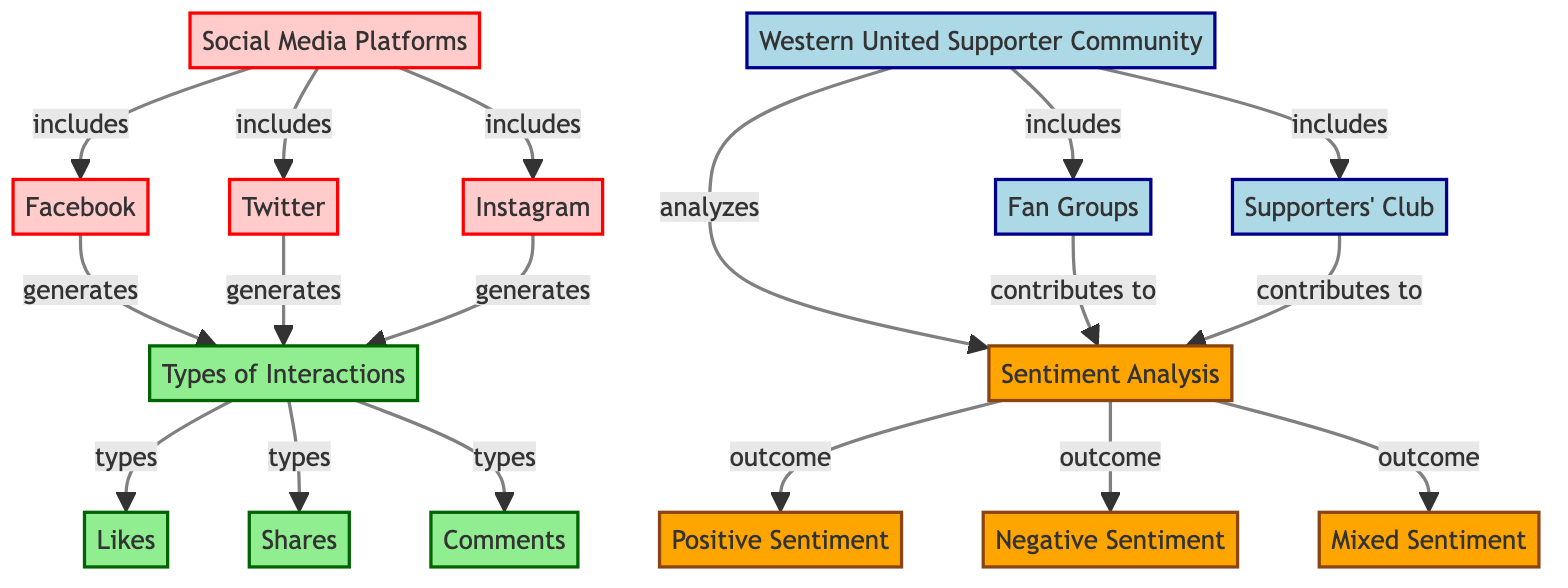What are the social media platforms listed in the diagram? The diagram lists three social media platforms under the "Social Media Platforms" node: Facebook, Twitter, and Instagram.
Answer: Facebook, Twitter, Instagram How many types of interactions are included in the diagram? The diagram identifies three types of interactions: Likes, Shares, and Comments, which are connected to the node "Types of Interactions."
Answer: 3 What sentiment outcomes are analyzed in the diagram? The diagram shows three sentiment outcomes stemming from the "Sentiment Analysis" node: Positive Sentiment, Negative Sentiment, and Mixed Sentiment.
Answer: Positive Sentiment, Negative Sentiment, Mixed Sentiment Which fan groups contribute to the sentiment analysis? The "Western United Supporter Community" includes two fan groups: Fan Groups and Supporters' Club, both of which contribute to sentiment analysis.
Answer: Fan Groups, Supporters' Club How do social media platforms generate interaction types? In the diagram, it's indicated that all three social media platforms (Facebook, Twitter, Instagram) generate types of interactions, linking these platforms directly to the "Types of Interactions" node. Thus, their relationship indicates that each platform leads to various forms of engagement.
Answer: Facebook, Twitter, Instagram generate types of interactions Which community analyzes the sentiment stemming from interactions? The "Western United Supporter Community" is shown to analyze sentiment in the diagram, indicating a focused group on sentiments derived from interactions.
Answer: Western United Supporter Community What is the relationship between fan groups and sentiment analysis? The diagram depicts that both Fan Groups and Supporters' Club contribute to the overall Sentiment Analysis, establishing a direct link showing how these groups influence sentiment findings.
Answer: Contributes to Sentiment Analysis Which type of interaction is not explicitly mentioned in the diagram? The diagram outlines Likes, Shares, and Comments as the types of interactions, thus it does not mention any other type of interaction such as Retweets or Reactions.
Answer: Retweets, Reactions How many community nodes are there in the diagram? The diagram shows only one community node, which is the "Western United Supporter Community." Under this node, there are fan groups, but the community itself is singular.
Answer: 1 